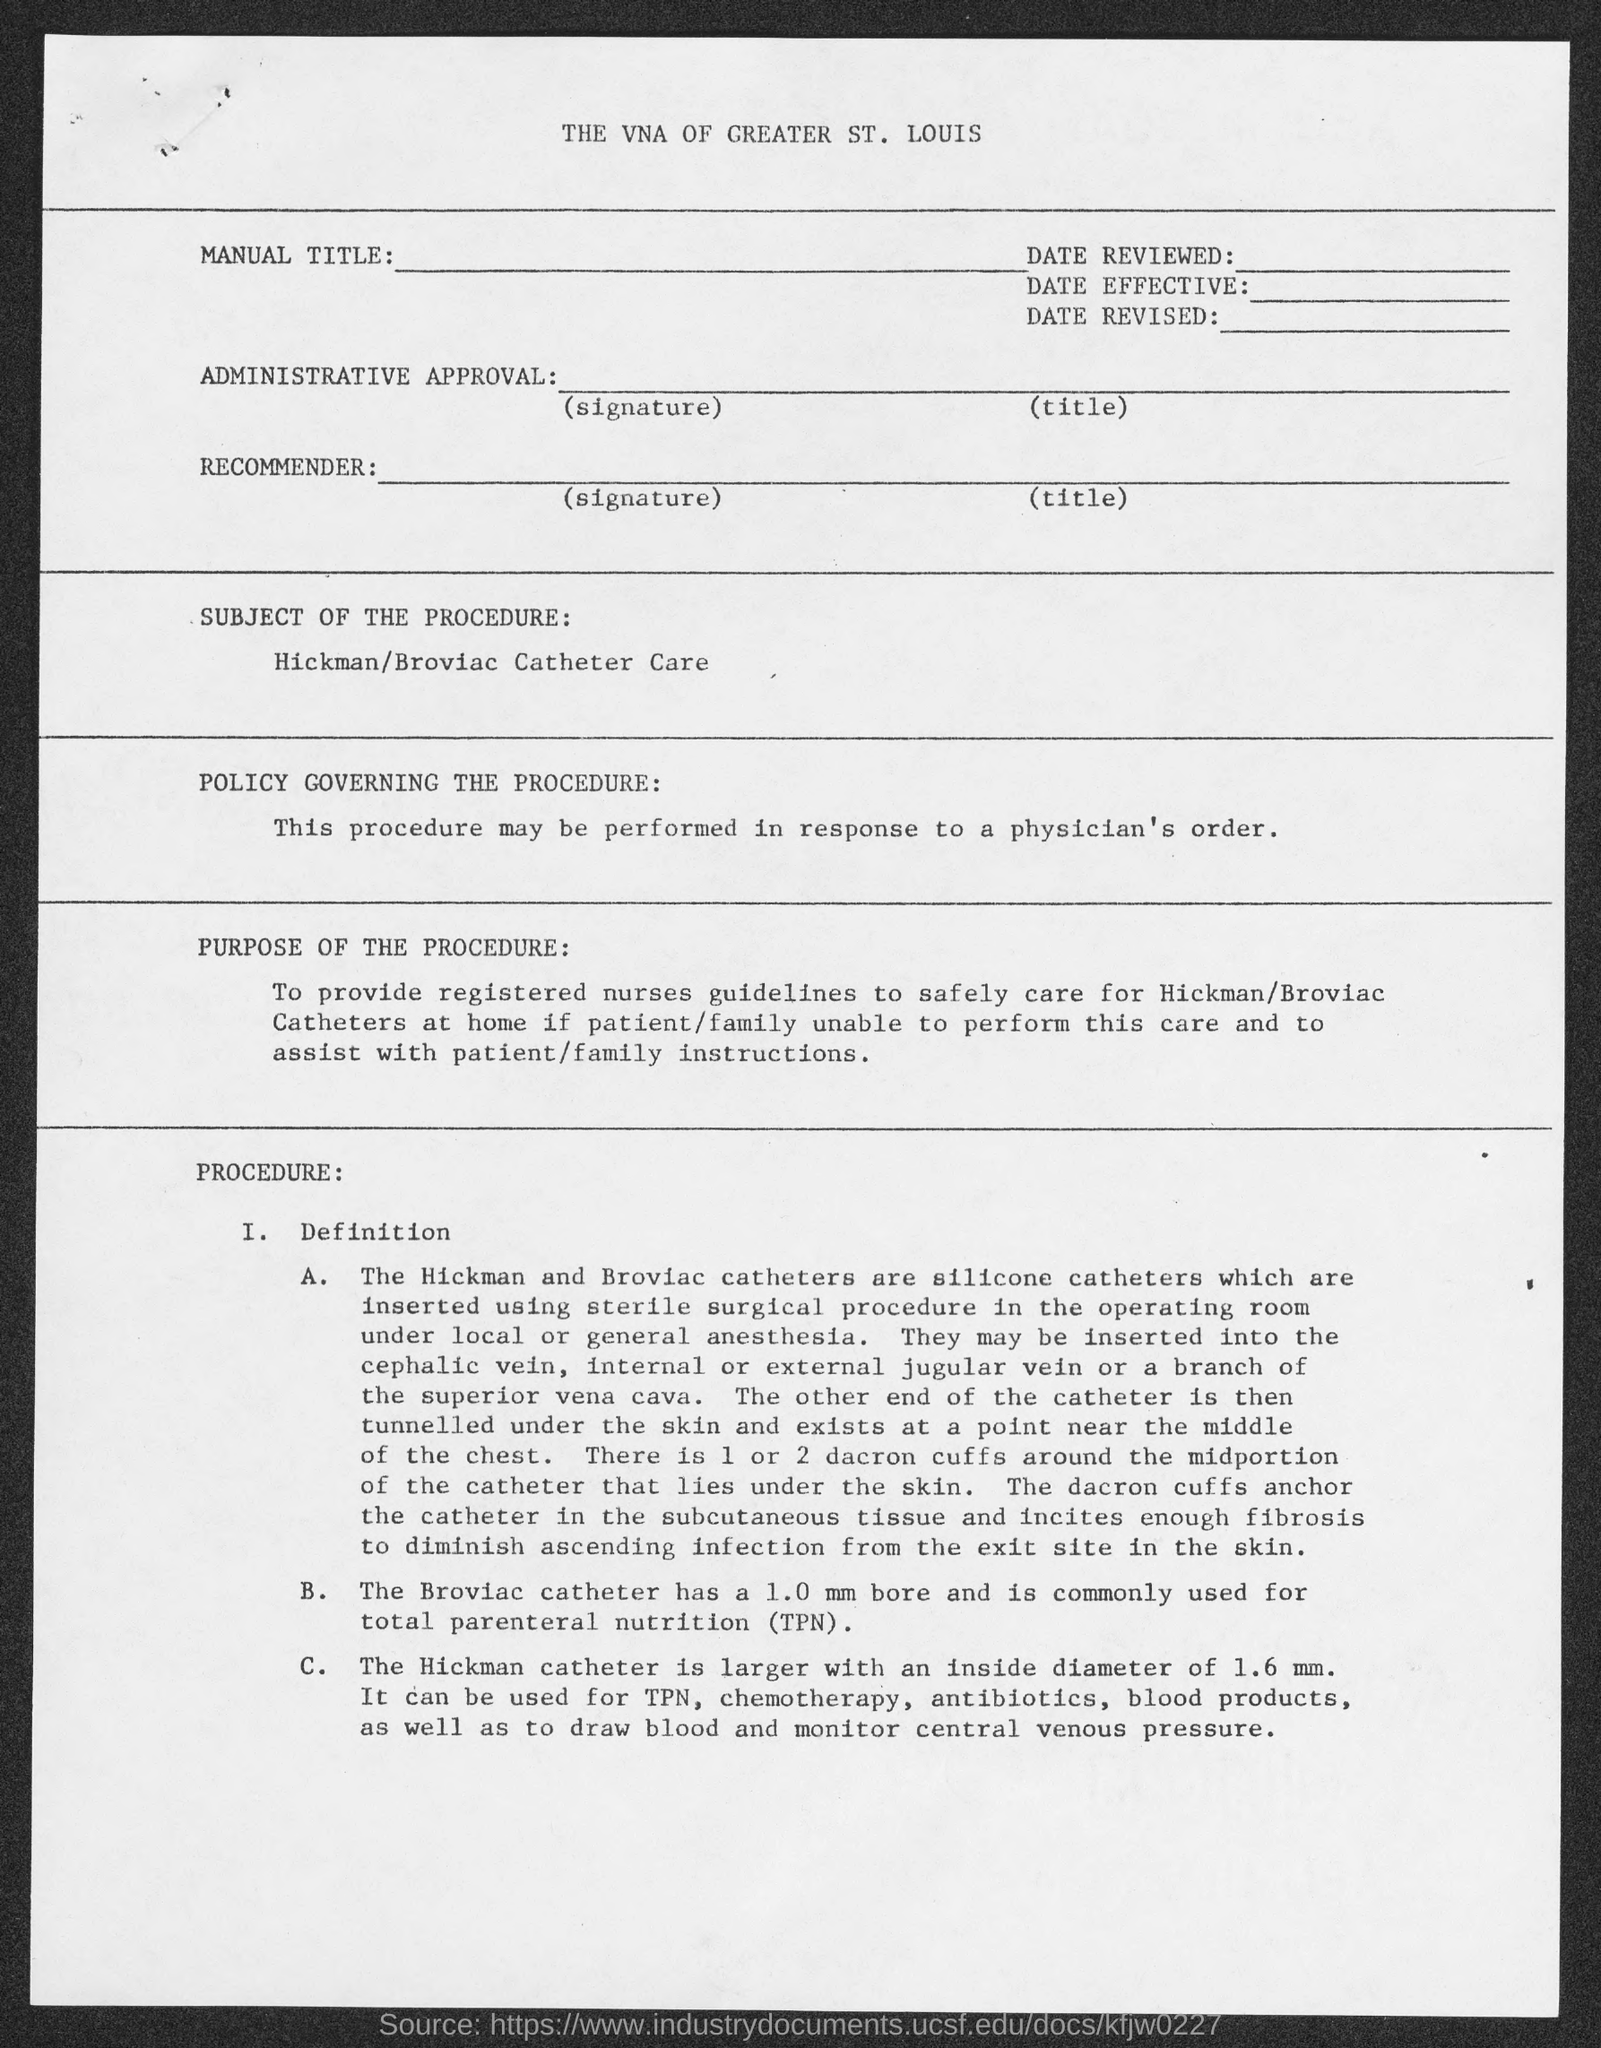List a handful of essential elements in this visual. The subject of the procedure is the care of Hickman/Broviac catheters. The Broviac Catheter is commonly used for the administration of total parenteral nutrition (TPN). 